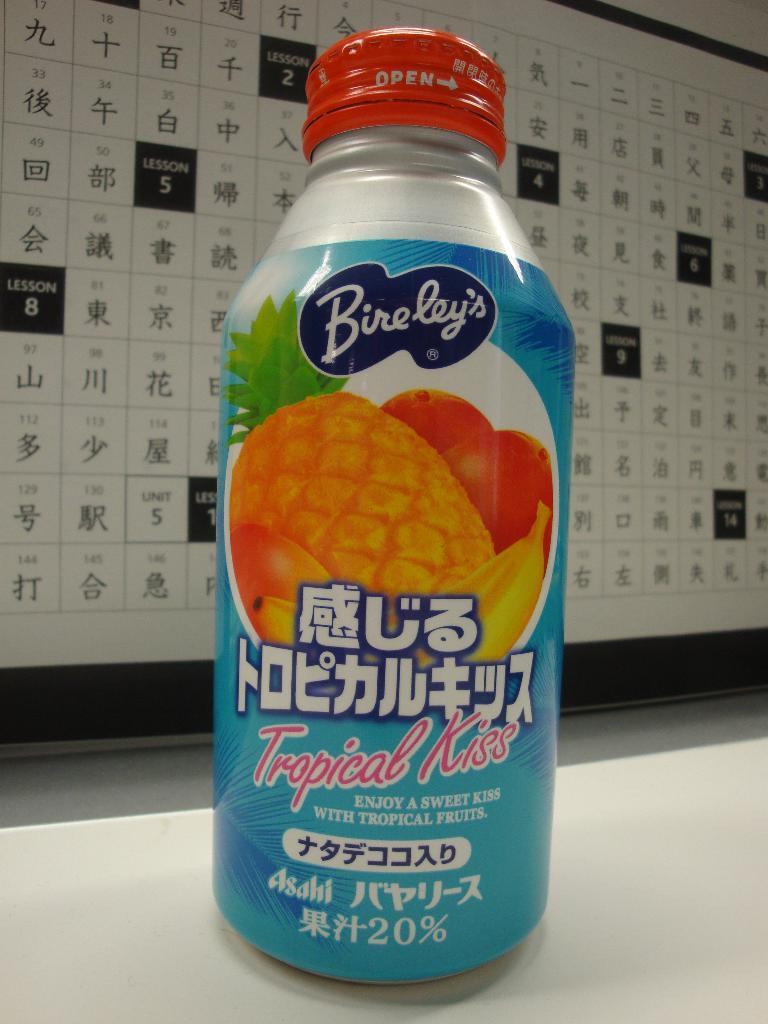<image>
Offer a succinct explanation of the picture presented. A bottle of Bireley's Tropical Kiss is in front of a chart. 